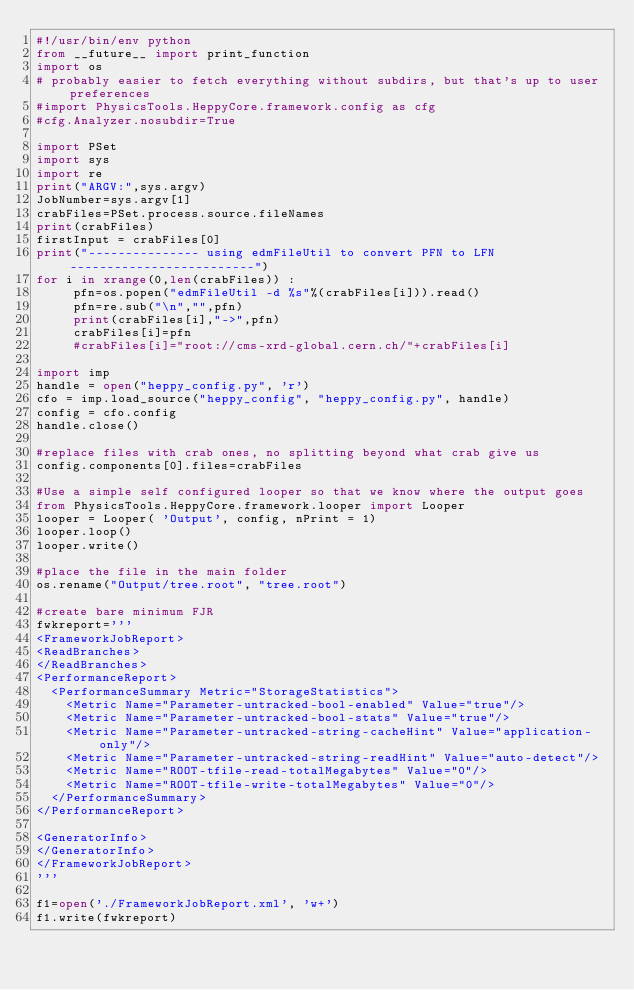Convert code to text. <code><loc_0><loc_0><loc_500><loc_500><_Python_>#!/usr/bin/env python
from __future__ import print_function
import os
# probably easier to fetch everything without subdirs, but that's up to user preferences
#import PhysicsTools.HeppyCore.framework.config as cfg
#cfg.Analyzer.nosubdir=True

import PSet
import sys
import re
print("ARGV:",sys.argv)
JobNumber=sys.argv[1]
crabFiles=PSet.process.source.fileNames
print(crabFiles)
firstInput = crabFiles[0]
print("--------------- using edmFileUtil to convert PFN to LFN -------------------------")
for i in xrange(0,len(crabFiles)) :
     pfn=os.popen("edmFileUtil -d %s"%(crabFiles[i])).read() 
     pfn=re.sub("\n","",pfn)
     print(crabFiles[i],"->",pfn)
     crabFiles[i]=pfn
     #crabFiles[i]="root://cms-xrd-global.cern.ch/"+crabFiles[i]

import imp
handle = open("heppy_config.py", 'r')
cfo = imp.load_source("heppy_config", "heppy_config.py", handle)
config = cfo.config
handle.close()

#replace files with crab ones, no splitting beyond what crab give us
config.components[0].files=crabFiles

#Use a simple self configured looper so that we know where the output goes
from PhysicsTools.HeppyCore.framework.looper import Looper
looper = Looper( 'Output', config, nPrint = 1)
looper.loop()
looper.write()

#place the file in the main folder
os.rename("Output/tree.root", "tree.root")

#create bare minimum FJR
fwkreport='''
<FrameworkJobReport>
<ReadBranches>
</ReadBranches>
<PerformanceReport>
  <PerformanceSummary Metric="StorageStatistics">
    <Metric Name="Parameter-untracked-bool-enabled" Value="true"/>
    <Metric Name="Parameter-untracked-bool-stats" Value="true"/>
    <Metric Name="Parameter-untracked-string-cacheHint" Value="application-only"/>
    <Metric Name="Parameter-untracked-string-readHint" Value="auto-detect"/>
    <Metric Name="ROOT-tfile-read-totalMegabytes" Value="0"/>
    <Metric Name="ROOT-tfile-write-totalMegabytes" Value="0"/>
  </PerformanceSummary>
</PerformanceReport>

<GeneratorInfo>
</GeneratorInfo>
</FrameworkJobReport>
'''

f1=open('./FrameworkJobReport.xml', 'w+')
f1.write(fwkreport)
</code> 